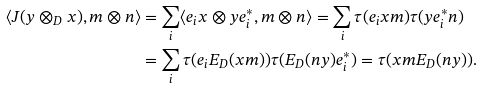<formula> <loc_0><loc_0><loc_500><loc_500>\langle J ( y \otimes _ { D } x ) , m \otimes n \rangle & = \sum _ { i } \langle e _ { i } x \otimes y e _ { i } ^ { * } , m \otimes n \rangle = \sum _ { i } \tau ( e _ { i } x m ) \tau ( y e _ { i } ^ { * } n ) \\ & = \sum _ { i } \tau ( e _ { i } E _ { D } ( x m ) ) \tau ( E _ { D } ( n y ) e _ { i } ^ { * } ) = \tau ( x m E _ { D } ( n y ) ) .</formula> 